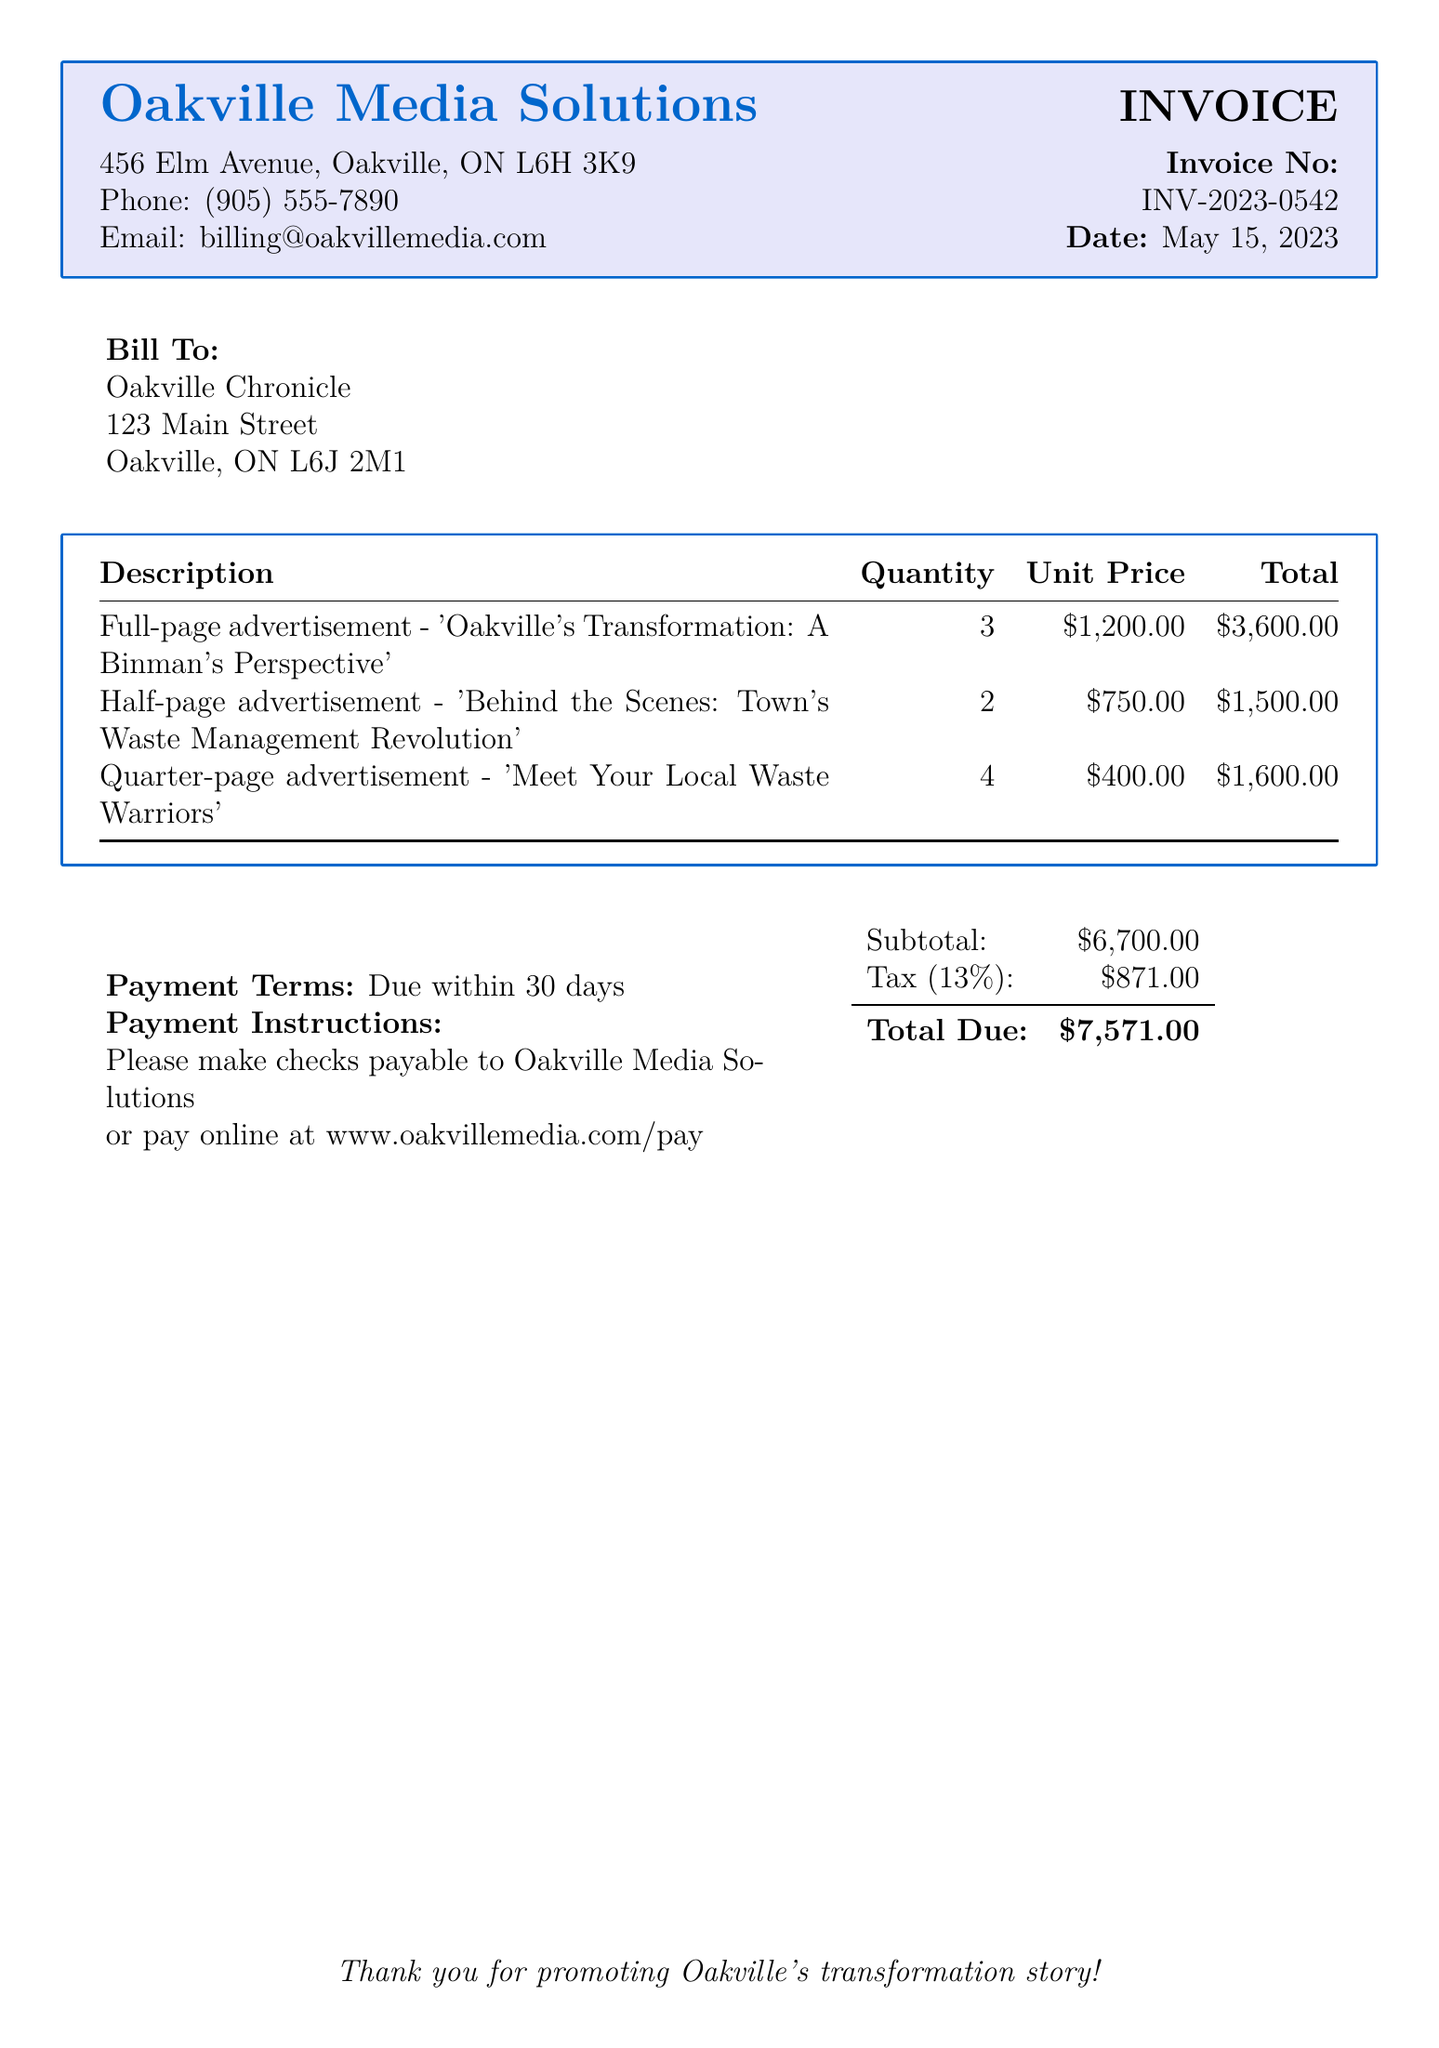What is the invoice number? The invoice number is clearly stated in the document, which is INV-2023-0542.
Answer: INV-2023-0542 What is the date of the invoice? The date is shown next to the invoice number, indicating when it was issued.
Answer: May 15, 2023 Who is the bill to? The "Bill To" section specifies the recipient of the invoice.
Answer: Oakville Chronicle What is the total amount due? The total amount due is calculated from the subtotal and tax sections provided.
Answer: $7,571.00 How many full-page advertisements were purchased? The quantity of full-page advertisements is listed in the table of descriptions.
Answer: 3 What is the unit price of a half-page advertisement? The unit price for half-page advertisements is found in the pricing section of the document.
Answer: $750.00 What is the subtotal before tax? The subtotal is provided in the payment summary section of the document.
Answer: $6,700.00 What is the tax rate applied? The tax rate is specified as a percentage in the document.
Answer: 13% What is the payment term? The payment terms indicate the time frame for which payment is expected.
Answer: Due within 30 days 